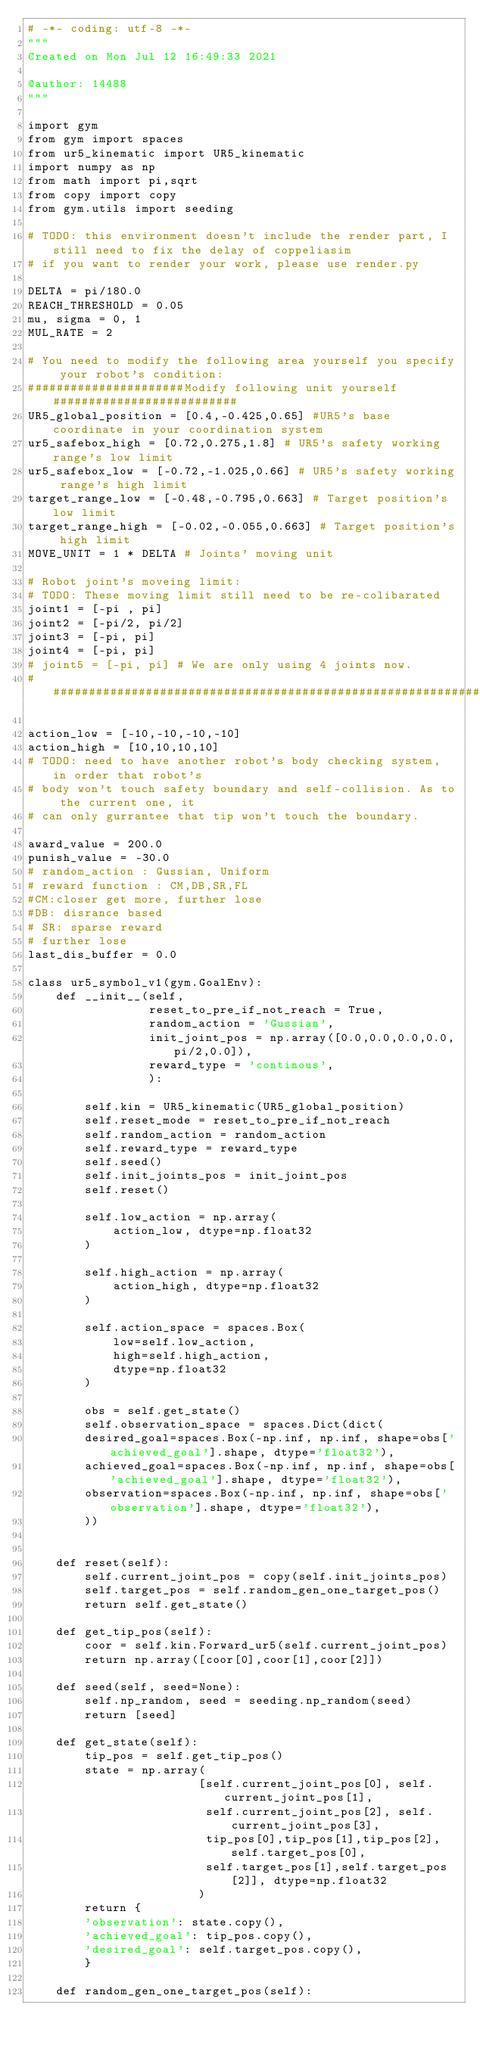<code> <loc_0><loc_0><loc_500><loc_500><_Python_># -*- coding: utf-8 -*-
"""
Created on Mon Jul 12 16:49:33 2021

@author: 14488
"""

import gym
from gym import spaces
from ur5_kinematic import UR5_kinematic
import numpy as np
from math import pi,sqrt
from copy import copy
from gym.utils import seeding

# TODO: this environment doesn't include the render part, I still need to fix the delay of coppeliasim
# if you want to render your work, please use render.py

DELTA = pi/180.0
REACH_THRESHOLD = 0.05
mu, sigma = 0, 1
MUL_RATE = 2

# You need to modify the following area yourself you specify your robot's condition:
######################Modify following unit yourself##########################
UR5_global_position = [0.4,-0.425,0.65] #UR5's base coordinate in your coordination system
ur5_safebox_high = [0.72,0.275,1.8] # UR5's safety working range's low limit
ur5_safebox_low = [-0.72,-1.025,0.66] # UR5's safety working range's high limit
target_range_low = [-0.48,-0.795,0.663] # Target position's low limit
target_range_high = [-0.02,-0.055,0.663] # Target position's high limit
MOVE_UNIT = 1 * DELTA # Joints' moving unit

# Robot joint's moveing limit:
# TODO: These moving limit still need to be re-colibarated
joint1 = [-pi , pi]
joint2 = [-pi/2, pi/2]
joint3 = [-pi, pi]
joint4 = [-pi, pi]
# joint5 = [-pi, pi] # We are only using 4 joints now.
##############################################################################

action_low = [-10,-10,-10,-10]
action_high = [10,10,10,10]
# TODO: need to have another robot's body checking system, in order that robot's 
# body won't touch safety boundary and self-collision. As to the current one, it 
# can only gurrantee that tip won't touch the boundary.

award_value = 200.0
punish_value = -30.0
# random_action : Gussian, Uniform
# reward function : CM,DB,SR,FL
#CM:closer get more, further lose
#DB: disrance based
# SR: sparse reward
# further lose
last_dis_buffer = 0.0

class ur5_symbol_v1(gym.GoalEnv):
    def __init__(self,
                 reset_to_pre_if_not_reach = True,
                 random_action = 'Gussian',
                 init_joint_pos = np.array([0.0,0.0,0.0,0.0,pi/2,0.0]),
                 reward_type = 'continous',
                 ):
        
        self.kin = UR5_kinematic(UR5_global_position)
        self.reset_mode = reset_to_pre_if_not_reach
        self.random_action = random_action
        self.reward_type = reward_type
        self.seed()
        self.init_joints_pos = init_joint_pos
        self.reset()

        self.low_action = np.array(
            action_low, dtype=np.float32
        )
        
        self.high_action = np.array(
            action_high, dtype=np.float32
        )
        
        self.action_space = spaces.Box(
            low=self.low_action,
            high=self.high_action,
            dtype=np.float32
        )
        
        obs = self.get_state()
        self.observation_space = spaces.Dict(dict(
        desired_goal=spaces.Box(-np.inf, np.inf, shape=obs['achieved_goal'].shape, dtype='float32'),
        achieved_goal=spaces.Box(-np.inf, np.inf, shape=obs['achieved_goal'].shape, dtype='float32'),
        observation=spaces.Box(-np.inf, np.inf, shape=obs['observation'].shape, dtype='float32'),
        ))
        

    def reset(self):
        self.current_joint_pos = copy(self.init_joints_pos)
        self.target_pos = self.random_gen_one_target_pos()
        return self.get_state()
    
    def get_tip_pos(self):
        coor = self.kin.Forward_ur5(self.current_joint_pos)
        return np.array([coor[0],coor[1],coor[2]])
        
    def seed(self, seed=None):
        self.np_random, seed = seeding.np_random(seed)
        return [seed]
        
    def get_state(self):
        tip_pos = self.get_tip_pos()
        state = np.array(
                        [self.current_joint_pos[0], self.current_joint_pos[1],
                         self.current_joint_pos[2], self.current_joint_pos[3],
                         tip_pos[0],tip_pos[1],tip_pos[2],self.target_pos[0],
                         self.target_pos[1],self.target_pos[2]], dtype=np.float32
                        )
        return {
        'observation': state.copy(),
        'achieved_goal': tip_pos.copy(),
        'desired_goal': self.target_pos.copy(),
        }
    
    def random_gen_one_target_pos(self):</code> 